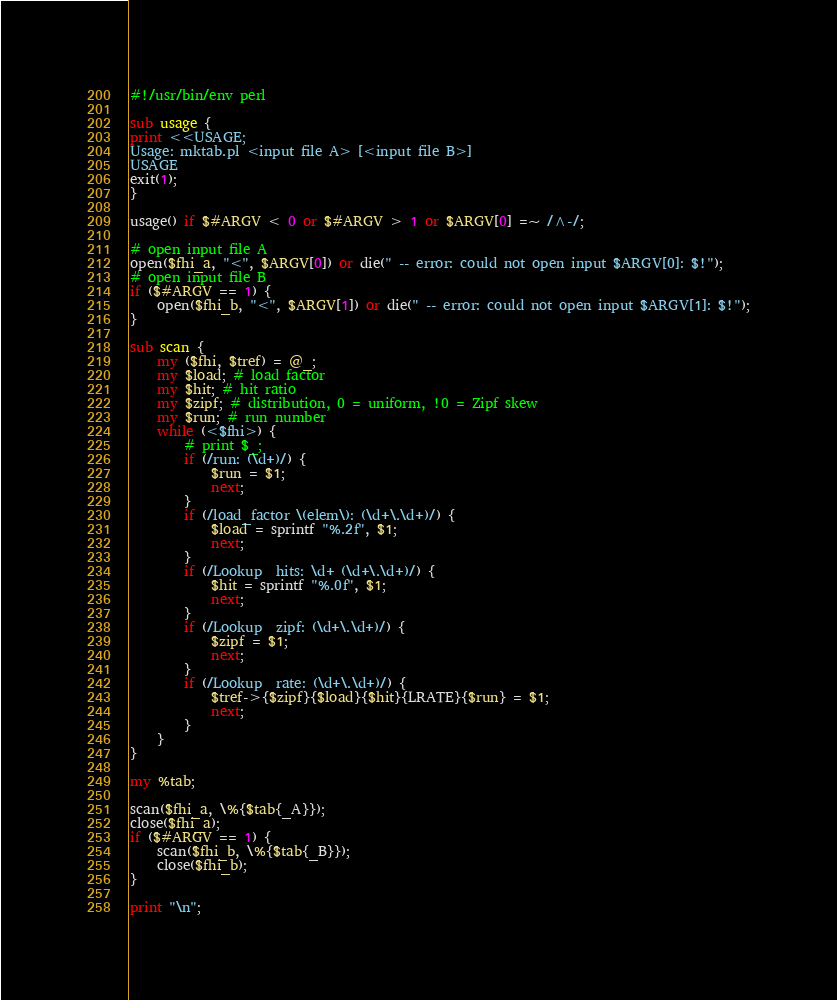<code> <loc_0><loc_0><loc_500><loc_500><_Perl_>#!/usr/bin/env perl

sub usage {
print <<USAGE;
Usage: mktab.pl <input file A> [<input file B>]
USAGE
exit(1);
}

usage() if $#ARGV < 0 or $#ARGV > 1 or $ARGV[0] =~ /^-/;

# open input file A
open($fhi_a, "<", $ARGV[0]) or die(" -- error: could not open input $ARGV[0]: $!");
# open input file B
if ($#ARGV == 1) {
	open($fhi_b, "<", $ARGV[1]) or die(" -- error: could not open input $ARGV[1]: $!");
}

sub scan {
	my ($fhi, $tref) = @_;
	my $load; # load factor
	my $hit; # hit ratio
	my $zipf; # distribution, 0 = uniform, !0 = Zipf skew
	my $run; # run number
	while (<$fhi>) {
		# print $_;
		if (/run: (\d+)/) {
			$run = $1;
			next;
		}
		if (/load_factor \(elem\): (\d+\.\d+)/) {
			$load = sprintf "%.2f", $1;
			next;
		}
		if (/Lookup  hits: \d+ (\d+\.\d+)/) {
			$hit = sprintf "%.0f", $1;
			next;
		}
		if (/Lookup  zipf: (\d+\.\d+)/) {
			$zipf = $1;
			next;
		}
		if (/Lookup  rate: (\d+\.\d+)/) {
			$tref->{$zipf}{$load}{$hit}{LRATE}{$run} = $1;
			next;
		}
	}
}

my %tab;

scan($fhi_a, \%{$tab{_A}});
close($fhi_a);
if ($#ARGV == 1) {
	scan($fhi_b, \%{$tab{_B}});
	close($fhi_b);
}

print "\n";</code> 